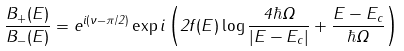<formula> <loc_0><loc_0><loc_500><loc_500>\frac { B _ { + } ( E ) } { B _ { - } ( E ) } = e ^ { i ( \nu - \pi / 2 ) } \exp i \left ( 2 f ( E ) \log \frac { 4 \hbar { \Omega } } { | E - E _ { c } | } + \frac { E - E _ { c } } { \hbar { \Omega } } \right )</formula> 